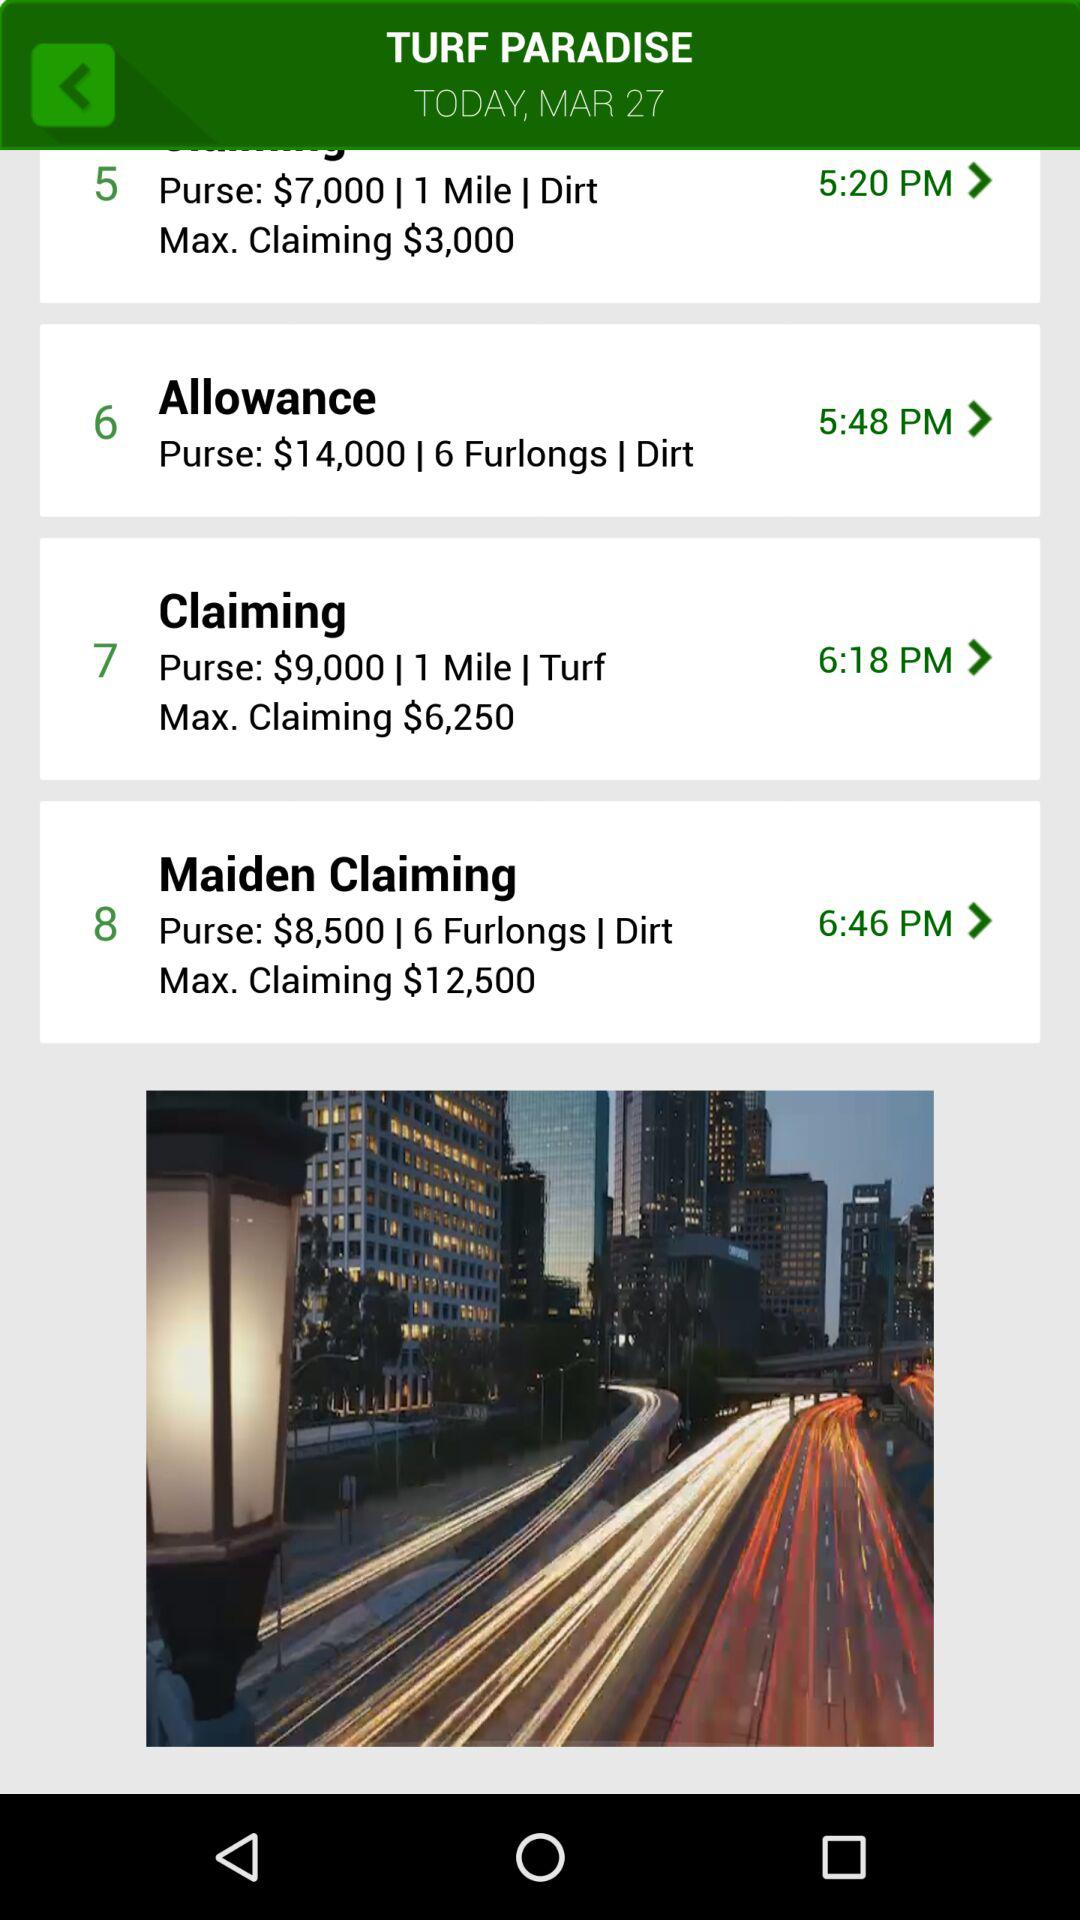What time is shown for the "Claiming"? The time shown for the "Claiming" is 6:18 PM. 